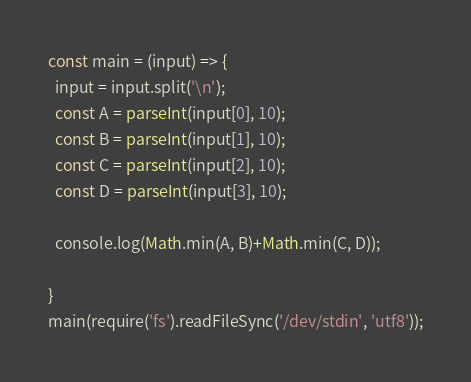<code> <loc_0><loc_0><loc_500><loc_500><_TypeScript_>const main = (input) => {
  input = input.split('\n');
  const A = parseInt(input[0], 10);
  const B = parseInt(input[1], 10);
  const C = parseInt(input[2], 10);
  const D = parseInt(input[3], 10);
  
  console.log(Math.min(A, B)+Math.min(C, D));
  
}
main(require('fs').readFileSync('/dev/stdin', 'utf8'));</code> 